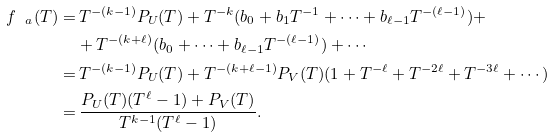<formula> <loc_0><loc_0><loc_500><loc_500>f _ { \ a } ( T ) = & \, T ^ { - ( k - 1 ) } P _ { U } ( T ) + T ^ { - k } ( b _ { 0 } + b _ { 1 } T ^ { - 1 } + \cdots + b _ { \ell - 1 } T ^ { - ( \ell - 1 ) } ) + \\ & + T ^ { - ( k + \ell ) } ( b _ { 0 } + \cdots + b _ { \ell - 1 } T ^ { - ( \ell - 1 ) } ) + \cdots \\ = & \, T ^ { - ( k - 1 ) } P _ { U } ( T ) + T ^ { - ( k + \ell - 1 ) } P _ { V } ( T ) ( 1 + T ^ { - \ell } + T ^ { - 2 \ell } + T ^ { - 3 \ell } + \cdots ) \\ = & \, \frac { P _ { U } ( T ) ( T ^ { \ell } - 1 ) + P _ { V } ( T ) } { T ^ { k - 1 } ( T ^ { \ell } - 1 ) } .</formula> 